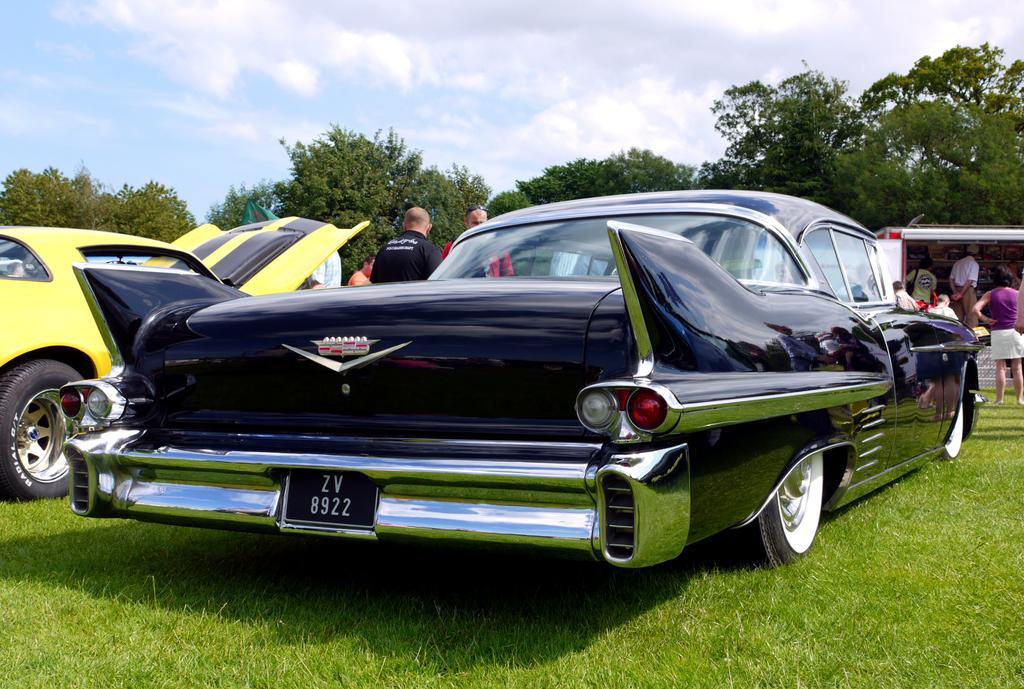Please provide a concise description of this image. In this image there are cars on a grassland, in the background there are people standing and there are trees and the sky. 